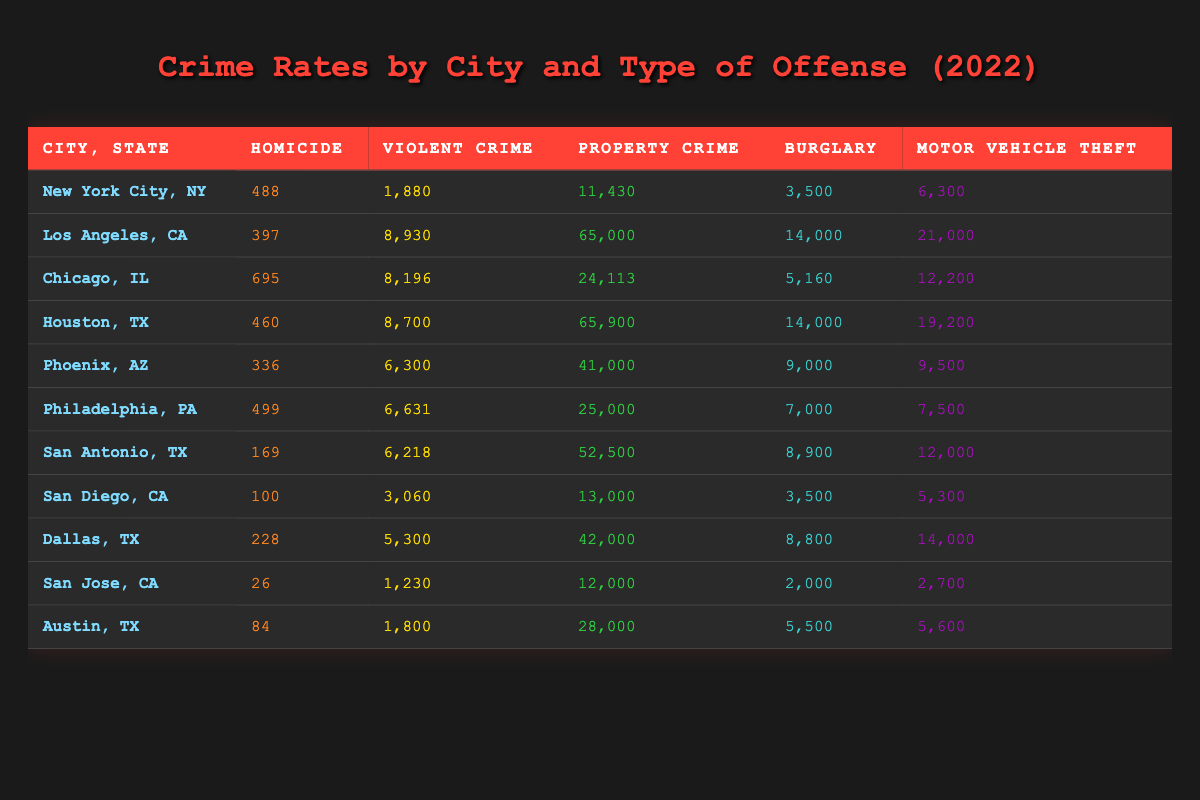What city had the highest number of homicides in 2022? In the table, we look at the Homicide column and identify the values. Chicago has the highest number of homicides at 695, followed by New York City with 488 and Los Angeles with 397. Thus, Chicago is the city with the highest number of homicides in 2022.
Answer: Chicago Which city had the lowest number of motor vehicle thefts? By examining the Motor Vehicle Theft column, we can see that San Jose has the lowest value at 2,700. Other cities, such as San Diego and Austin, have higher counts, confirming that San Jose records the least motor vehicle thefts.
Answer: San Jose What is the average number of violent crimes across the cities listed? We sum the violent crime values: 1,880 (New York City) + 8,930 (Los Angeles) + 8,196 (Chicago) + 8,700 (Houston) + 6,300 (Phoenix) + 6,631 (Philadelphia) + 6,218 (San Antonio) + 3,060 (San Diego) + 5,300 (Dallas) + 1,230 (San Jose) + 1,800 (Austin) = 58,635. There are 11 cities, so we divide 58,635 by 11 to get an average of approximately 5,336.82.
Answer: 5,336.82 Did San Antonio experience more burglaries than Philadelphia in 2022? Looking at the Burglary column, San Antonio has 8,900 burglaries, while Philadelphia has 7,000. Since 8,900 is greater than 7,000, it confirms that San Antonio had more burglaries than Philadelphia in that year.
Answer: Yes Which city had the highest total property crime rate? We can determine this by checking the Property Crime column values: New York City (11,430), Los Angeles (65,000), Chicago (24,113), Houston (65,900), Phoenix (41,000), Philadelphia (25,000), San Antonio (52,500), San Diego (13,000), Dallas (42,000), San Jose (12,000), and Austin (28,000). The highest value is 65,900, which belongs to Houston. Thus, Houston had the highest property crime rate.
Answer: Houston 